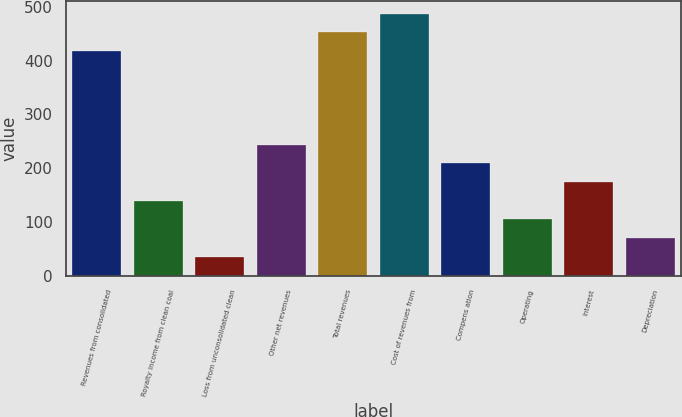Convert chart. <chart><loc_0><loc_0><loc_500><loc_500><bar_chart><fcel>Revenues from consolidated<fcel>Royalty income from clean coal<fcel>Loss from unconsolidated clean<fcel>Other net revenues<fcel>Total revenues<fcel>Cost of revenues from<fcel>Compens ation<fcel>Operating<fcel>Interest<fcel>Depreciation<nl><fcel>417.53<fcel>139.29<fcel>34.95<fcel>243.63<fcel>452.31<fcel>487.09<fcel>208.85<fcel>104.51<fcel>174.07<fcel>69.73<nl></chart> 